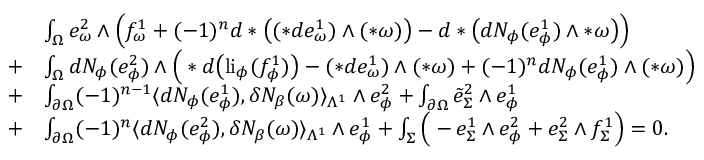Convert formula to latex. <formula><loc_0><loc_0><loc_500><loc_500>\begin{array} { r l } & { \int _ { \Omega } e _ { \omega } ^ { 2 } \wedge \left ( f _ { \omega } ^ { 1 } + ( - 1 ) ^ { n } d \ast \left ( ( \ast d e _ { \omega } ^ { 1 } ) \wedge ( \ast \omega ) \right ) - d \ast \left ( d N _ { \phi } ( e _ { \phi } ^ { 1 } ) \wedge \ast \omega \right ) \right ) } \\ { + } & { \int _ { \Omega } d N _ { \phi } ( e _ { \phi } ^ { 2 } ) \wedge \left ( \ast d \left ( l i _ { \phi } ( f _ { \phi } ^ { 1 } ) \right ) - ( \ast d e _ { \omega } ^ { 1 } ) \wedge ( \ast \omega ) + ( - 1 ) ^ { n } d N _ { \phi } ( e _ { \phi } ^ { 1 } ) \wedge ( \ast \omega ) \right ) } \\ { + } & { \int _ { \partial \Omega } ( - 1 ) ^ { n - 1 } \langle d N _ { \phi } ( e _ { \phi } ^ { 1 } ) , \delta N _ { \beta } ( \omega ) \rangle _ { \Lambda ^ { 1 } } \wedge e _ { \phi } ^ { 2 } + \int _ { \partial \Omega } \tilde { e } _ { \Sigma } ^ { 2 } \wedge e _ { \phi } ^ { 1 } } \\ { + } & { \int _ { \partial \Omega } ( - 1 ) ^ { n } \langle d N _ { \phi } ( e _ { \phi } ^ { 2 } ) , \delta N _ { \beta } ( \omega ) \rangle _ { \Lambda ^ { 1 } } \wedge e _ { \phi } ^ { 1 } + \int _ { \Sigma } \left ( - e _ { \Sigma } ^ { 1 } \wedge e _ { \phi } ^ { 2 } + e _ { \Sigma } ^ { 2 } \wedge f _ { \Sigma } ^ { 1 } \right ) = 0 . } \end{array}</formula> 